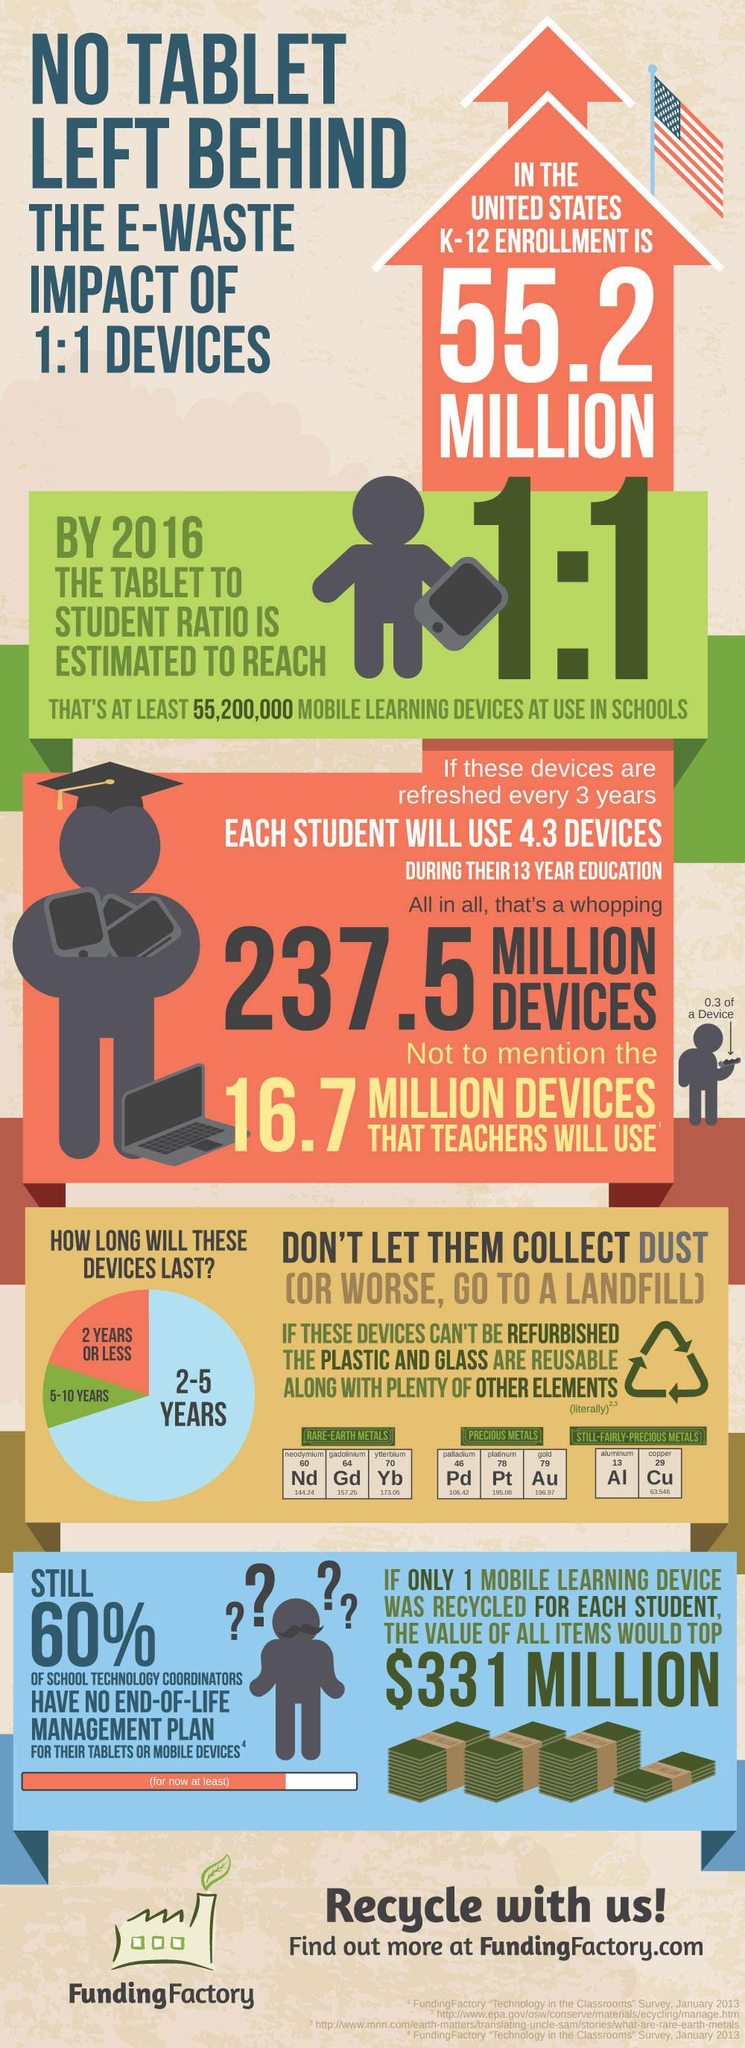Indicate a few pertinent items in this graphic. The atomic number of aluminum is 13. The atomic mass of copper is 63.546. The typical lifespan of mobile learning devices is 2-5 years. Gold is represented by the chemical symbol Au. The total number of devices that students and teachers would use during a 13-year period is 254.2 million devices. 